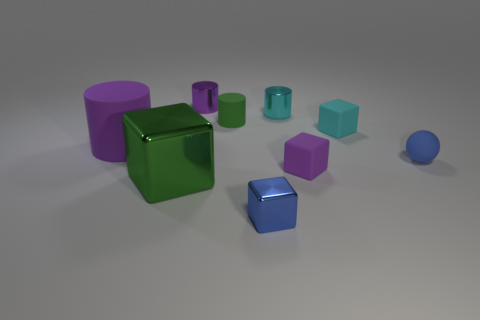There is a tiny cyan object behind the small matte cylinder; is its shape the same as the tiny blue rubber thing?
Keep it short and to the point. No. There is a small matte thing that is right of the small matte block behind the matte cube that is in front of the blue matte sphere; what is its color?
Offer a terse response. Blue. Are any blue blocks visible?
Ensure brevity in your answer.  Yes. How many other objects are the same size as the green block?
Offer a very short reply. 1. Does the big matte object have the same color as the small block in front of the big green block?
Offer a terse response. No. What number of objects are either tiny red spheres or tiny matte spheres?
Give a very brief answer. 1. Is there anything else that has the same color as the large block?
Keep it short and to the point. Yes. Are the green cylinder and the purple object behind the tiny cyan matte thing made of the same material?
Make the answer very short. No. There is a blue object that is in front of the big metallic thing that is behind the small blue cube; what shape is it?
Offer a very short reply. Cube. There is a metal thing that is both on the left side of the blue shiny block and behind the large block; what is its shape?
Offer a terse response. Cylinder. 